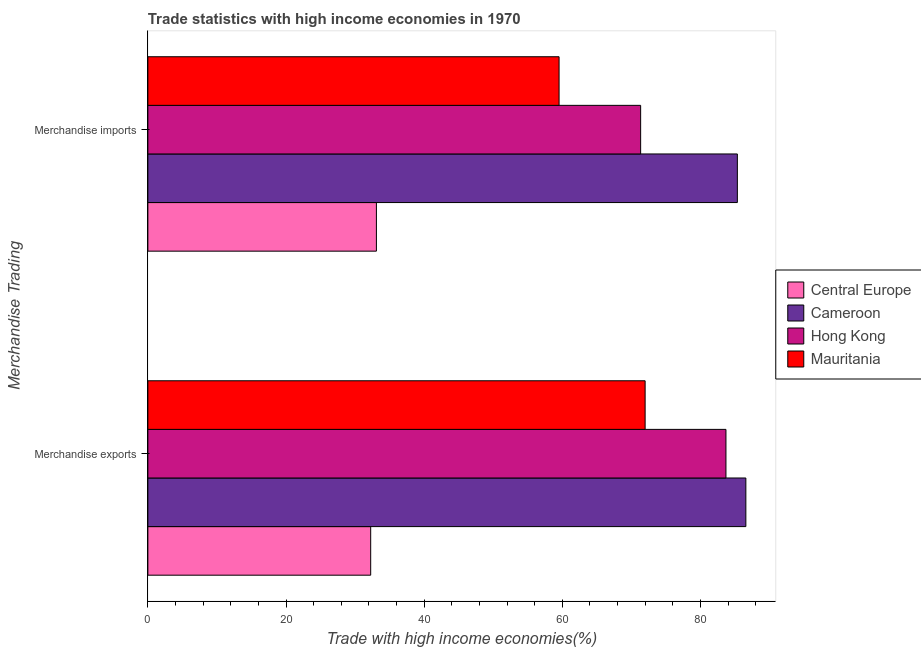How many groups of bars are there?
Provide a succinct answer. 2. Are the number of bars on each tick of the Y-axis equal?
Offer a terse response. Yes. How many bars are there on the 1st tick from the top?
Offer a terse response. 4. What is the label of the 2nd group of bars from the top?
Offer a terse response. Merchandise exports. What is the merchandise exports in Hong Kong?
Your answer should be very brief. 83.7. Across all countries, what is the maximum merchandise imports?
Your answer should be very brief. 85.35. Across all countries, what is the minimum merchandise exports?
Ensure brevity in your answer.  32.26. In which country was the merchandise exports maximum?
Your answer should be very brief. Cameroon. In which country was the merchandise imports minimum?
Provide a short and direct response. Central Europe. What is the total merchandise imports in the graph?
Ensure brevity in your answer.  249.32. What is the difference between the merchandise imports in Central Europe and that in Hong Kong?
Keep it short and to the point. -38.26. What is the difference between the merchandise imports in Central Europe and the merchandise exports in Hong Kong?
Give a very brief answer. -50.61. What is the average merchandise imports per country?
Your answer should be very brief. 62.33. What is the difference between the merchandise exports and merchandise imports in Central Europe?
Your response must be concise. -0.83. What is the ratio of the merchandise exports in Hong Kong to that in Central Europe?
Make the answer very short. 2.59. Is the merchandise exports in Central Europe less than that in Hong Kong?
Your answer should be compact. Yes. What does the 4th bar from the top in Merchandise exports represents?
Ensure brevity in your answer.  Central Europe. What does the 1st bar from the bottom in Merchandise exports represents?
Offer a very short reply. Central Europe. How many countries are there in the graph?
Provide a succinct answer. 4. Are the values on the major ticks of X-axis written in scientific E-notation?
Offer a very short reply. No. Does the graph contain any zero values?
Your response must be concise. No. Where does the legend appear in the graph?
Ensure brevity in your answer.  Center right. How are the legend labels stacked?
Ensure brevity in your answer.  Vertical. What is the title of the graph?
Provide a short and direct response. Trade statistics with high income economies in 1970. What is the label or title of the X-axis?
Give a very brief answer. Trade with high income economies(%). What is the label or title of the Y-axis?
Ensure brevity in your answer.  Merchandise Trading. What is the Trade with high income economies(%) of Central Europe in Merchandise exports?
Your answer should be compact. 32.26. What is the Trade with high income economies(%) of Cameroon in Merchandise exports?
Your response must be concise. 86.58. What is the Trade with high income economies(%) in Hong Kong in Merchandise exports?
Ensure brevity in your answer.  83.7. What is the Trade with high income economies(%) in Mauritania in Merchandise exports?
Your answer should be very brief. 72. What is the Trade with high income economies(%) of Central Europe in Merchandise imports?
Your response must be concise. 33.09. What is the Trade with high income economies(%) in Cameroon in Merchandise imports?
Your response must be concise. 85.35. What is the Trade with high income economies(%) in Hong Kong in Merchandise imports?
Your response must be concise. 71.35. What is the Trade with high income economies(%) in Mauritania in Merchandise imports?
Ensure brevity in your answer.  59.54. Across all Merchandise Trading, what is the maximum Trade with high income economies(%) of Central Europe?
Your answer should be compact. 33.09. Across all Merchandise Trading, what is the maximum Trade with high income economies(%) of Cameroon?
Your response must be concise. 86.58. Across all Merchandise Trading, what is the maximum Trade with high income economies(%) of Hong Kong?
Offer a terse response. 83.7. Across all Merchandise Trading, what is the maximum Trade with high income economies(%) of Mauritania?
Offer a terse response. 72. Across all Merchandise Trading, what is the minimum Trade with high income economies(%) in Central Europe?
Offer a terse response. 32.26. Across all Merchandise Trading, what is the minimum Trade with high income economies(%) in Cameroon?
Provide a short and direct response. 85.35. Across all Merchandise Trading, what is the minimum Trade with high income economies(%) in Hong Kong?
Your answer should be very brief. 71.35. Across all Merchandise Trading, what is the minimum Trade with high income economies(%) of Mauritania?
Keep it short and to the point. 59.54. What is the total Trade with high income economies(%) of Central Europe in the graph?
Make the answer very short. 65.35. What is the total Trade with high income economies(%) in Cameroon in the graph?
Your response must be concise. 171.93. What is the total Trade with high income economies(%) in Hong Kong in the graph?
Make the answer very short. 155.04. What is the total Trade with high income economies(%) in Mauritania in the graph?
Your answer should be compact. 131.53. What is the difference between the Trade with high income economies(%) in Central Europe in Merchandise exports and that in Merchandise imports?
Your answer should be very brief. -0.83. What is the difference between the Trade with high income economies(%) in Cameroon in Merchandise exports and that in Merchandise imports?
Offer a very short reply. 1.23. What is the difference between the Trade with high income economies(%) of Hong Kong in Merchandise exports and that in Merchandise imports?
Keep it short and to the point. 12.35. What is the difference between the Trade with high income economies(%) in Mauritania in Merchandise exports and that in Merchandise imports?
Offer a very short reply. 12.46. What is the difference between the Trade with high income economies(%) of Central Europe in Merchandise exports and the Trade with high income economies(%) of Cameroon in Merchandise imports?
Your answer should be very brief. -53.09. What is the difference between the Trade with high income economies(%) in Central Europe in Merchandise exports and the Trade with high income economies(%) in Hong Kong in Merchandise imports?
Make the answer very short. -39.08. What is the difference between the Trade with high income economies(%) of Central Europe in Merchandise exports and the Trade with high income economies(%) of Mauritania in Merchandise imports?
Give a very brief answer. -27.27. What is the difference between the Trade with high income economies(%) in Cameroon in Merchandise exports and the Trade with high income economies(%) in Hong Kong in Merchandise imports?
Keep it short and to the point. 15.23. What is the difference between the Trade with high income economies(%) in Cameroon in Merchandise exports and the Trade with high income economies(%) in Mauritania in Merchandise imports?
Keep it short and to the point. 27.04. What is the difference between the Trade with high income economies(%) in Hong Kong in Merchandise exports and the Trade with high income economies(%) in Mauritania in Merchandise imports?
Provide a succinct answer. 24.16. What is the average Trade with high income economies(%) in Central Europe per Merchandise Trading?
Your answer should be compact. 32.68. What is the average Trade with high income economies(%) of Cameroon per Merchandise Trading?
Offer a terse response. 85.96. What is the average Trade with high income economies(%) of Hong Kong per Merchandise Trading?
Offer a terse response. 77.52. What is the average Trade with high income economies(%) of Mauritania per Merchandise Trading?
Your response must be concise. 65.77. What is the difference between the Trade with high income economies(%) in Central Europe and Trade with high income economies(%) in Cameroon in Merchandise exports?
Keep it short and to the point. -54.32. What is the difference between the Trade with high income economies(%) of Central Europe and Trade with high income economies(%) of Hong Kong in Merchandise exports?
Keep it short and to the point. -51.44. What is the difference between the Trade with high income economies(%) in Central Europe and Trade with high income economies(%) in Mauritania in Merchandise exports?
Keep it short and to the point. -39.73. What is the difference between the Trade with high income economies(%) of Cameroon and Trade with high income economies(%) of Hong Kong in Merchandise exports?
Offer a terse response. 2.88. What is the difference between the Trade with high income economies(%) of Cameroon and Trade with high income economies(%) of Mauritania in Merchandise exports?
Offer a very short reply. 14.58. What is the difference between the Trade with high income economies(%) in Hong Kong and Trade with high income economies(%) in Mauritania in Merchandise exports?
Provide a succinct answer. 11.7. What is the difference between the Trade with high income economies(%) in Central Europe and Trade with high income economies(%) in Cameroon in Merchandise imports?
Provide a succinct answer. -52.26. What is the difference between the Trade with high income economies(%) of Central Europe and Trade with high income economies(%) of Hong Kong in Merchandise imports?
Provide a succinct answer. -38.26. What is the difference between the Trade with high income economies(%) of Central Europe and Trade with high income economies(%) of Mauritania in Merchandise imports?
Your answer should be very brief. -26.45. What is the difference between the Trade with high income economies(%) of Cameroon and Trade with high income economies(%) of Hong Kong in Merchandise imports?
Your answer should be very brief. 14. What is the difference between the Trade with high income economies(%) of Cameroon and Trade with high income economies(%) of Mauritania in Merchandise imports?
Provide a short and direct response. 25.81. What is the difference between the Trade with high income economies(%) in Hong Kong and Trade with high income economies(%) in Mauritania in Merchandise imports?
Keep it short and to the point. 11.81. What is the ratio of the Trade with high income economies(%) in Cameroon in Merchandise exports to that in Merchandise imports?
Offer a terse response. 1.01. What is the ratio of the Trade with high income economies(%) in Hong Kong in Merchandise exports to that in Merchandise imports?
Make the answer very short. 1.17. What is the ratio of the Trade with high income economies(%) of Mauritania in Merchandise exports to that in Merchandise imports?
Give a very brief answer. 1.21. What is the difference between the highest and the second highest Trade with high income economies(%) of Central Europe?
Keep it short and to the point. 0.83. What is the difference between the highest and the second highest Trade with high income economies(%) of Cameroon?
Provide a short and direct response. 1.23. What is the difference between the highest and the second highest Trade with high income economies(%) in Hong Kong?
Offer a terse response. 12.35. What is the difference between the highest and the second highest Trade with high income economies(%) in Mauritania?
Ensure brevity in your answer.  12.46. What is the difference between the highest and the lowest Trade with high income economies(%) in Central Europe?
Offer a very short reply. 0.83. What is the difference between the highest and the lowest Trade with high income economies(%) of Cameroon?
Make the answer very short. 1.23. What is the difference between the highest and the lowest Trade with high income economies(%) of Hong Kong?
Provide a succinct answer. 12.35. What is the difference between the highest and the lowest Trade with high income economies(%) of Mauritania?
Ensure brevity in your answer.  12.46. 